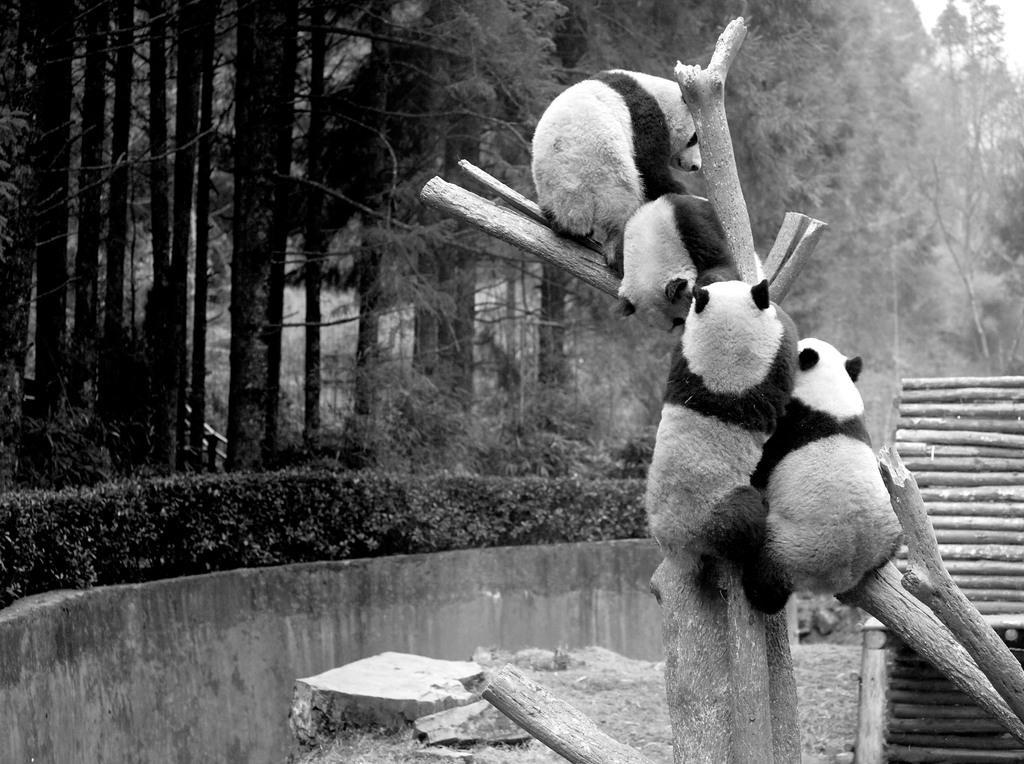Could you give a brief overview of what you see in this image? In the picture we can see a tree branch on it, we can see some panda are sitting on it and around the tree we can see a wall on it we can see some plants and behind it we can see trees. 